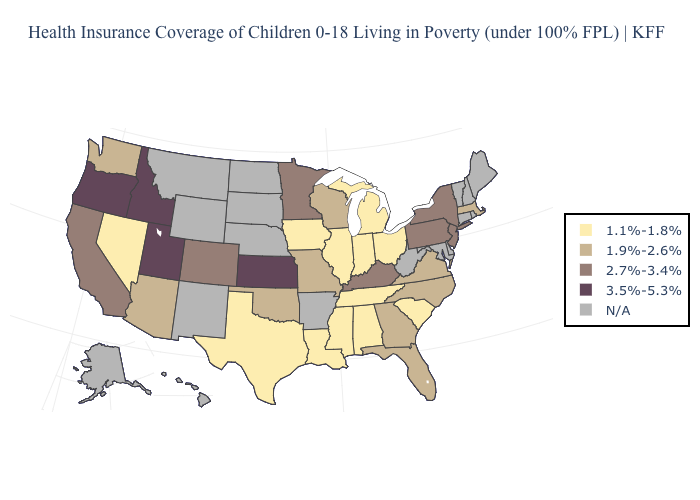Is the legend a continuous bar?
Short answer required. No. What is the value of Delaware?
Concise answer only. N/A. Name the states that have a value in the range N/A?
Give a very brief answer. Alaska, Arkansas, Connecticut, Delaware, Hawaii, Maine, Maryland, Montana, Nebraska, New Hampshire, New Mexico, North Dakota, Rhode Island, South Dakota, Vermont, West Virginia, Wyoming. What is the highest value in the South ?
Short answer required. 2.7%-3.4%. Name the states that have a value in the range 2.7%-3.4%?
Short answer required. California, Colorado, Kentucky, Minnesota, New Jersey, New York, Pennsylvania. Name the states that have a value in the range N/A?
Answer briefly. Alaska, Arkansas, Connecticut, Delaware, Hawaii, Maine, Maryland, Montana, Nebraska, New Hampshire, New Mexico, North Dakota, Rhode Island, South Dakota, Vermont, West Virginia, Wyoming. What is the highest value in states that border Mississippi?
Short answer required. 1.1%-1.8%. Name the states that have a value in the range 3.5%-5.3%?
Answer briefly. Idaho, Kansas, Oregon, Utah. Name the states that have a value in the range 1.9%-2.6%?
Quick response, please. Arizona, Florida, Georgia, Massachusetts, Missouri, North Carolina, Oklahoma, Virginia, Washington, Wisconsin. Does the map have missing data?
Answer briefly. Yes. Which states have the lowest value in the USA?
Give a very brief answer. Alabama, Illinois, Indiana, Iowa, Louisiana, Michigan, Mississippi, Nevada, Ohio, South Carolina, Tennessee, Texas. Does the first symbol in the legend represent the smallest category?
Keep it brief. Yes. Is the legend a continuous bar?
Concise answer only. No. What is the lowest value in the MidWest?
Concise answer only. 1.1%-1.8%. 